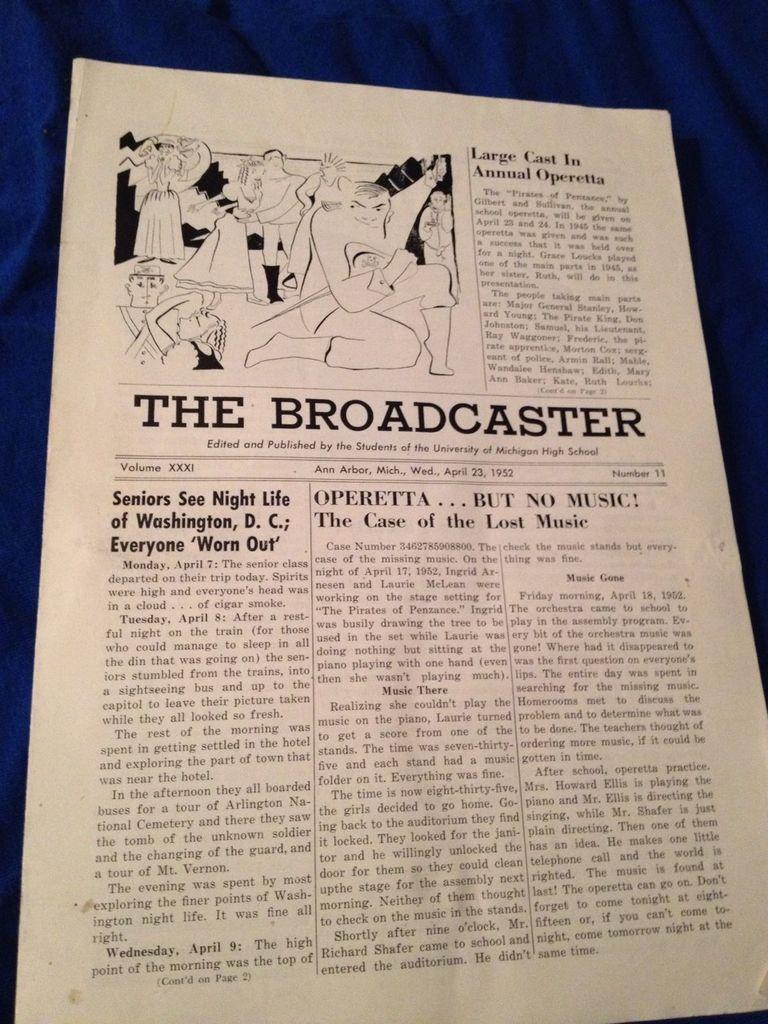Provide a one-sentence caption for the provided image. Volume XXXI of The Broadcaster published by students of University of Michigan High School. 